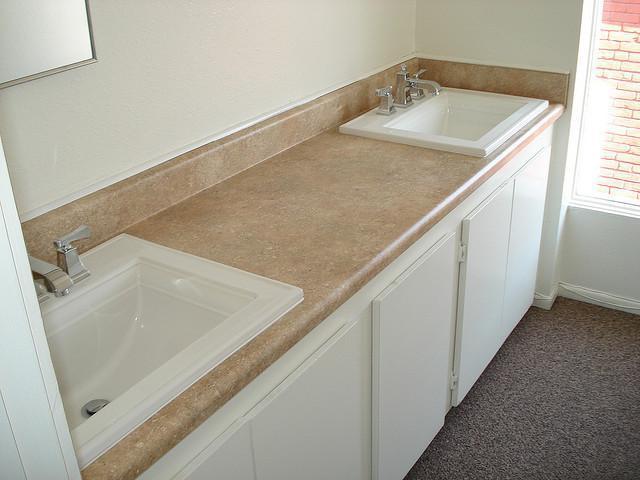How many sinks in the room?
Give a very brief answer. 2. How many sinks can you see?
Give a very brief answer. 2. 